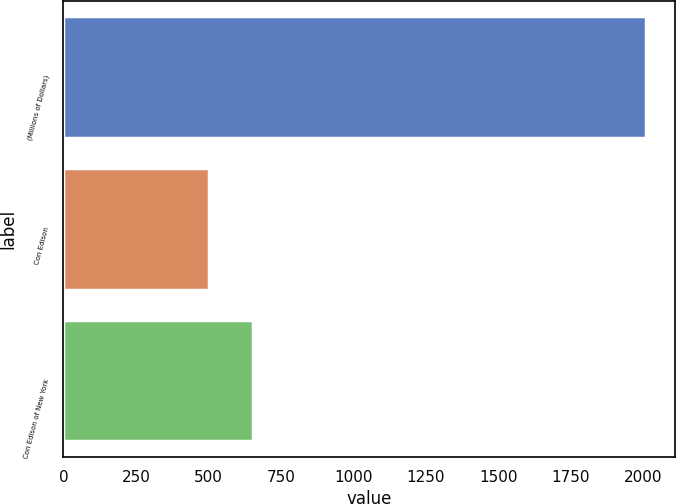<chart> <loc_0><loc_0><loc_500><loc_500><bar_chart><fcel>(Millions of Dollars)<fcel>Con Edison<fcel>Con Edison of New York<nl><fcel>2010<fcel>504<fcel>654.6<nl></chart> 